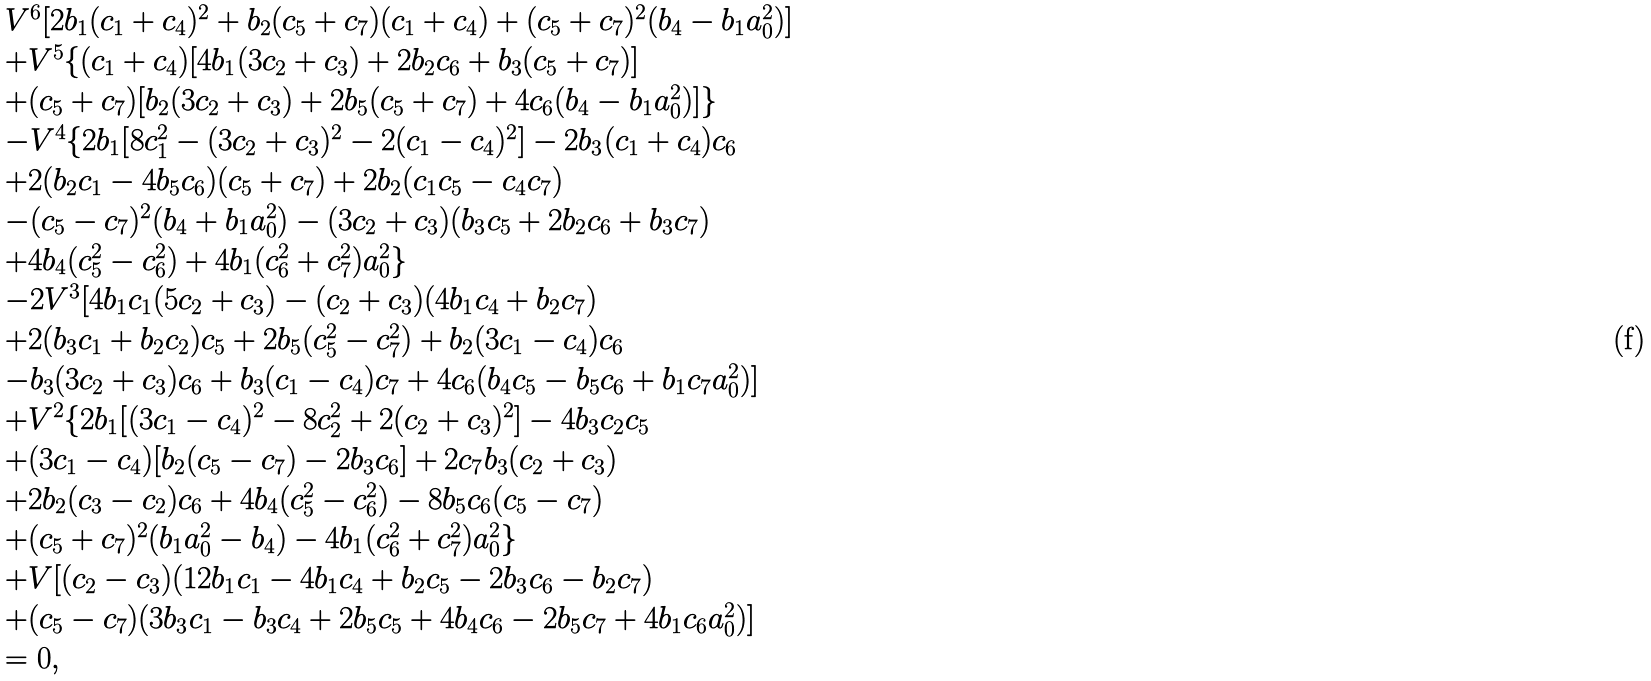Convert formula to latex. <formula><loc_0><loc_0><loc_500><loc_500>\begin{array} { l } V ^ { 6 } [ 2 b _ { 1 } ( c _ { 1 } + c _ { 4 } ) ^ { 2 } + b _ { 2 } ( c _ { 5 } + c _ { 7 } ) ( c _ { 1 } + c _ { 4 } ) + ( c _ { 5 } + c _ { 7 } ) ^ { 2 } ( b _ { 4 } - b _ { 1 } a _ { 0 } ^ { 2 } ) ] \\ + V ^ { 5 } \{ ( c _ { 1 } + c _ { 4 } ) [ 4 b _ { 1 } ( 3 c _ { 2 } + c _ { 3 } ) + 2 b _ { 2 } c _ { 6 } + b _ { 3 } ( c _ { 5 } + c _ { 7 } ) ] \\ + ( c _ { 5 } + c _ { 7 } ) [ b _ { 2 } ( 3 c _ { 2 } + c _ { 3 } ) + 2 b _ { 5 } ( c _ { 5 } + c _ { 7 } ) + 4 c _ { 6 } ( b _ { 4 } - b _ { 1 } a _ { 0 } ^ { 2 } ) ] \} \\ - V ^ { 4 } \{ 2 b _ { 1 } [ 8 c _ { 1 } ^ { 2 } - ( 3 c _ { 2 } + c _ { 3 } ) ^ { 2 } - 2 ( c _ { 1 } - c _ { 4 } ) ^ { 2 } ] - 2 b _ { 3 } ( c _ { 1 } + c _ { 4 } ) c _ { 6 } \\ + 2 ( b _ { 2 } c _ { 1 } - 4 b _ { 5 } c _ { 6 } ) ( c _ { 5 } + c _ { 7 } ) + 2 b _ { 2 } ( c _ { 1 } c _ { 5 } - c _ { 4 } c _ { 7 } ) \\ - ( c _ { 5 } - c _ { 7 } ) ^ { 2 } ( b _ { 4 } + b _ { 1 } a _ { 0 } ^ { 2 } ) - ( 3 c _ { 2 } + c _ { 3 } ) ( b _ { 3 } c _ { 5 } + 2 b _ { 2 } c _ { 6 } + b _ { 3 } c _ { 7 } ) \\ + 4 b _ { 4 } ( c _ { 5 } ^ { 2 } - c _ { 6 } ^ { 2 } ) + 4 b _ { 1 } ( c _ { 6 } ^ { 2 } + c _ { 7 } ^ { 2 } ) a _ { 0 } ^ { 2 } \} \\ - 2 V ^ { 3 } [ 4 b _ { 1 } c _ { 1 } ( 5 c _ { 2 } + c _ { 3 } ) - ( c _ { 2 } + c _ { 3 } ) ( 4 b _ { 1 } c _ { 4 } + b _ { 2 } c _ { 7 } ) \\ + 2 ( b _ { 3 } c _ { 1 } + b _ { 2 } c _ { 2 } ) c _ { 5 } + 2 b _ { 5 } ( c _ { 5 } ^ { 2 } - c _ { 7 } ^ { 2 } ) + b _ { 2 } ( 3 c _ { 1 } - c _ { 4 } ) c _ { 6 } \\ - b _ { 3 } ( 3 c _ { 2 } + c _ { 3 } ) c _ { 6 } + b _ { 3 } ( c _ { 1 } - c _ { 4 } ) c _ { 7 } + 4 c _ { 6 } ( b _ { 4 } c _ { 5 } - b _ { 5 } c _ { 6 } + b _ { 1 } c _ { 7 } a _ { 0 } ^ { 2 } ) ] \\ + V ^ { 2 } \{ 2 b _ { 1 } [ ( 3 c _ { 1 } - c _ { 4 } ) ^ { 2 } - 8 c _ { 2 } ^ { 2 } + 2 ( c _ { 2 } + c _ { 3 } ) ^ { 2 } ] - 4 b _ { 3 } c _ { 2 } c _ { 5 } \\ + ( 3 c _ { 1 } - c _ { 4 } ) [ b _ { 2 } ( c _ { 5 } - c _ { 7 } ) - 2 b _ { 3 } c _ { 6 } ] + 2 c _ { 7 } b _ { 3 } ( c _ { 2 } + c _ { 3 } ) \\ + 2 b _ { 2 } ( c _ { 3 } - c _ { 2 } ) c _ { 6 } + 4 b _ { 4 } ( c _ { 5 } ^ { 2 } - c _ { 6 } ^ { 2 } ) - 8 b _ { 5 } c _ { 6 } ( c _ { 5 } - c _ { 7 } ) \\ + ( c _ { 5 } + c _ { 7 } ) ^ { 2 } ( b _ { 1 } a _ { 0 } ^ { 2 } - b _ { 4 } ) - 4 b _ { 1 } ( c _ { 6 } ^ { 2 } + c _ { 7 } ^ { 2 } ) a _ { 0 } ^ { 2 } \} \\ + V [ ( c _ { 2 } - c _ { 3 } ) ( 1 2 b _ { 1 } c _ { 1 } - 4 b _ { 1 } c _ { 4 } + b _ { 2 } c _ { 5 } - 2 b _ { 3 } c _ { 6 } - b _ { 2 } c _ { 7 } ) \\ + ( c _ { 5 } - c _ { 7 } ) ( 3 b _ { 3 } c _ { 1 } - b _ { 3 } c _ { 4 } + 2 b _ { 5 } c _ { 5 } + 4 b _ { 4 } c _ { 6 } - 2 b _ { 5 } c _ { 7 } + 4 b _ { 1 } c _ { 6 } a _ { 0 } ^ { 2 } ) ] \\ = 0 , \end{array}</formula> 